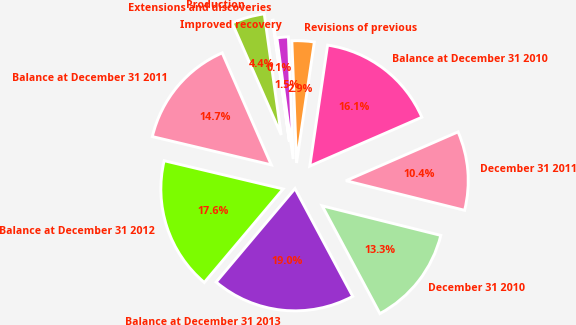Convert chart. <chart><loc_0><loc_0><loc_500><loc_500><pie_chart><fcel>Balance at December 31 2010<fcel>Revisions of previous<fcel>Improved recovery<fcel>Extensions and discoveries<fcel>Production<fcel>Balance at December 31 2011<fcel>Balance at December 31 2012<fcel>Balance at December 31 2013<fcel>December 31 2010<fcel>December 31 2011<nl><fcel>16.13%<fcel>2.94%<fcel>1.51%<fcel>0.09%<fcel>4.36%<fcel>14.71%<fcel>17.56%<fcel>18.98%<fcel>13.28%<fcel>10.43%<nl></chart> 